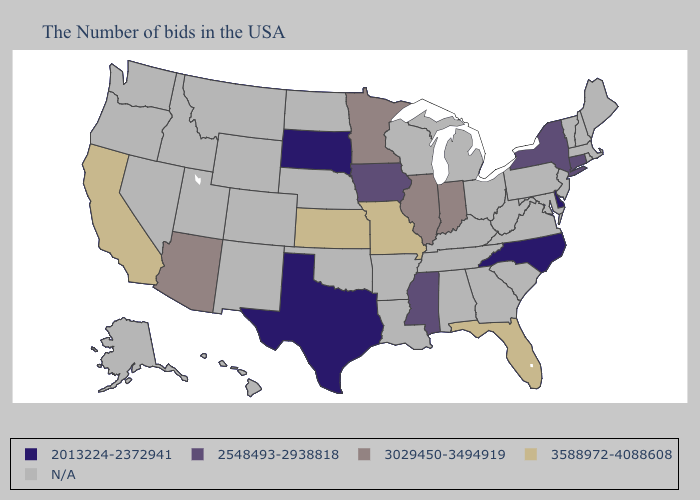What is the value of Minnesota?
Quick response, please. 3029450-3494919. Does Arizona have the lowest value in the West?
Answer briefly. Yes. What is the value of Indiana?
Give a very brief answer. 3029450-3494919. Which states have the lowest value in the USA?
Be succinct. Delaware, North Carolina, Texas, South Dakota. What is the value of Rhode Island?
Write a very short answer. N/A. Name the states that have a value in the range 2013224-2372941?
Be succinct. Delaware, North Carolina, Texas, South Dakota. Name the states that have a value in the range N/A?
Be succinct. Maine, Massachusetts, Rhode Island, New Hampshire, Vermont, New Jersey, Maryland, Pennsylvania, Virginia, South Carolina, West Virginia, Ohio, Georgia, Michigan, Kentucky, Alabama, Tennessee, Wisconsin, Louisiana, Arkansas, Nebraska, Oklahoma, North Dakota, Wyoming, Colorado, New Mexico, Utah, Montana, Idaho, Nevada, Washington, Oregon, Alaska, Hawaii. Does Arizona have the highest value in the USA?
Give a very brief answer. No. Does the map have missing data?
Concise answer only. Yes. What is the value of Colorado?
Quick response, please. N/A. 